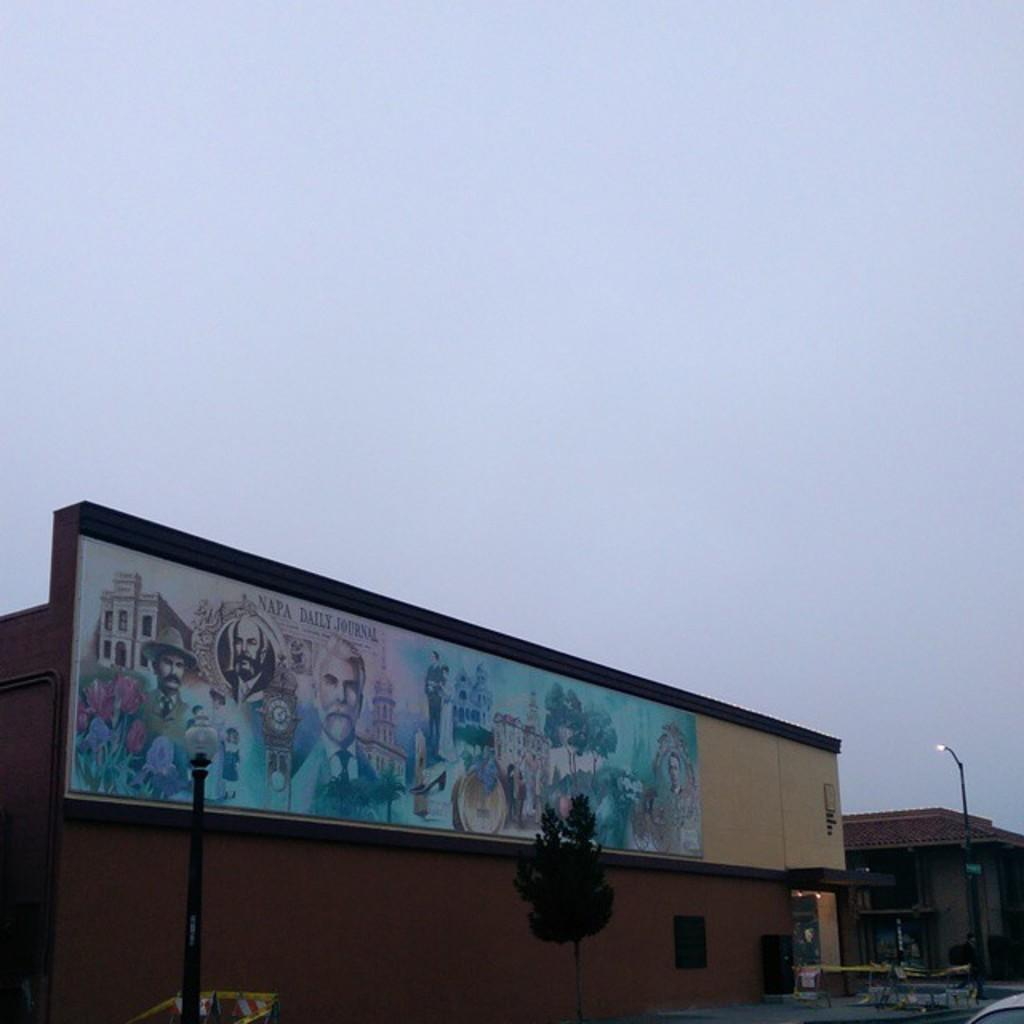Provide a one-sentence caption for the provided image. A mural done by or for the Napa Daily journal. 